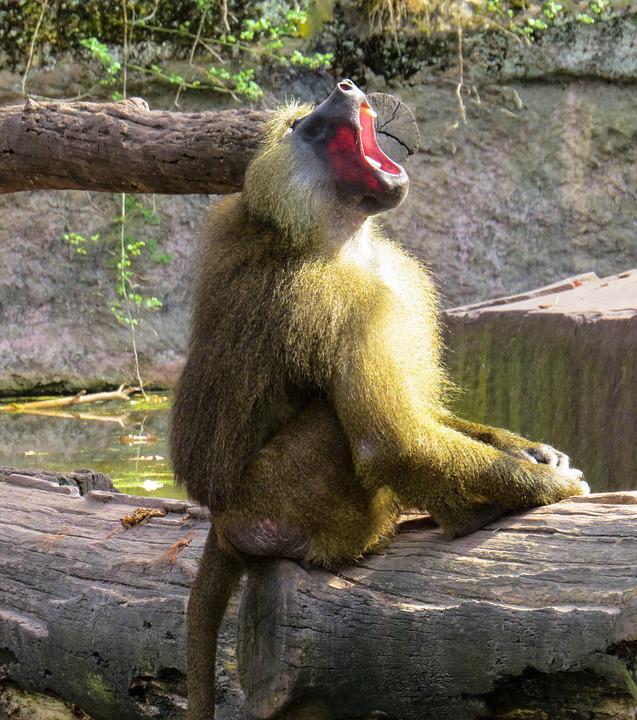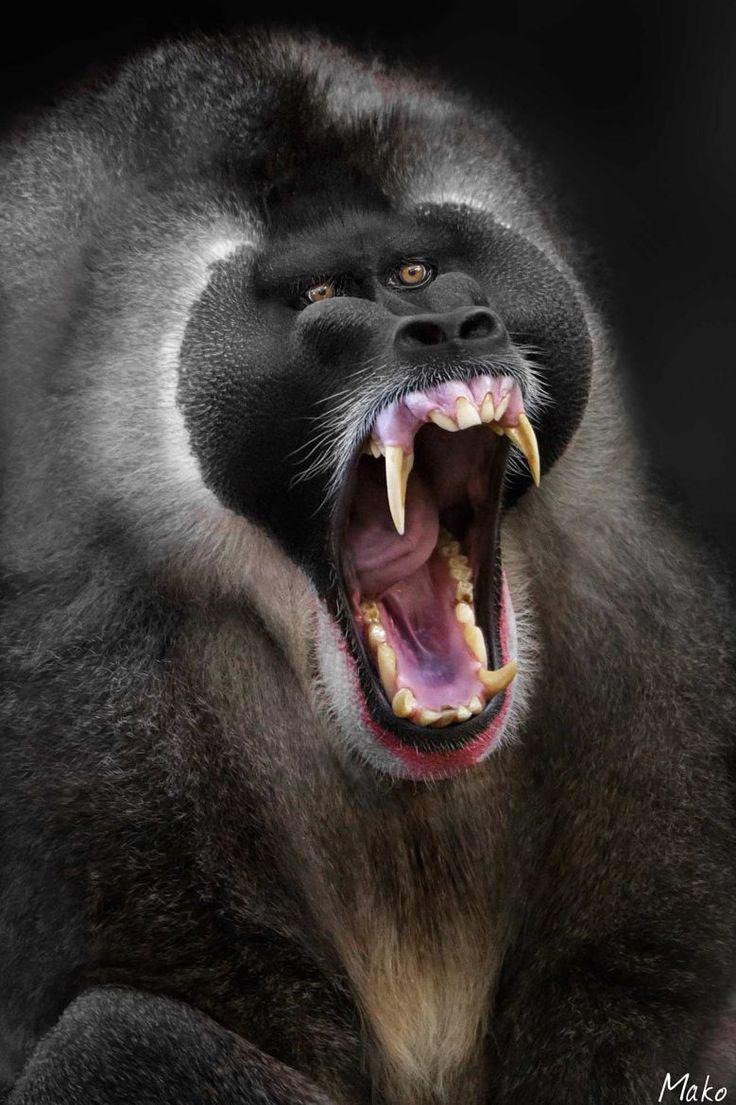The first image is the image on the left, the second image is the image on the right. Analyze the images presented: Is the assertion "At least one primate is on a log or branch." valid? Answer yes or no. Yes. The first image is the image on the left, the second image is the image on the right. Analyze the images presented: Is the assertion "Each image shows one open-mouthed, fang-baring monkey, and one image shows a monkey with an upturned snout and open mouth." valid? Answer yes or no. Yes. 